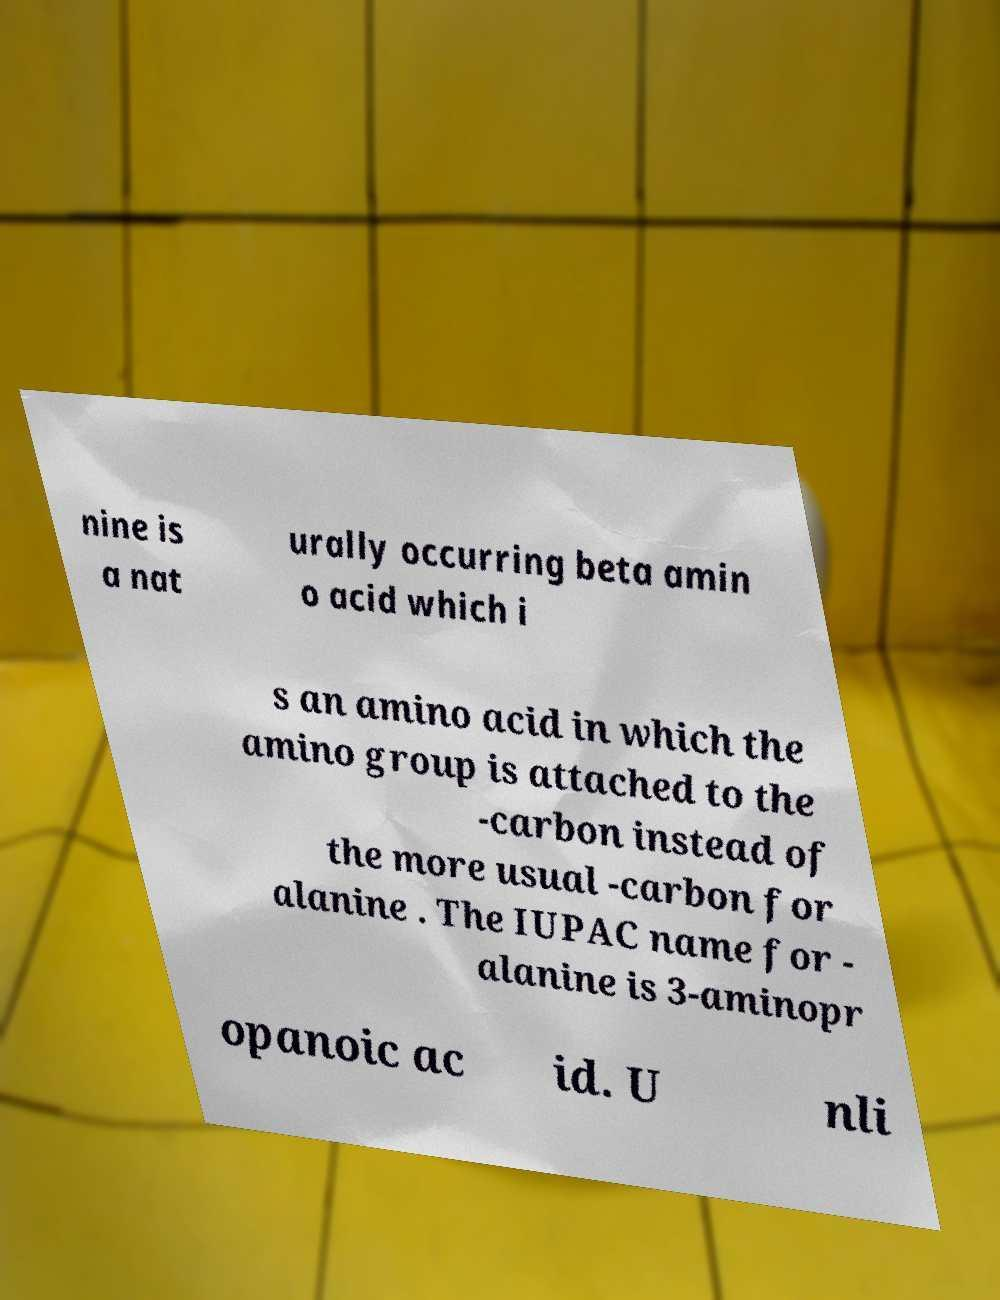Can you accurately transcribe the text from the provided image for me? nine is a nat urally occurring beta amin o acid which i s an amino acid in which the amino group is attached to the -carbon instead of the more usual -carbon for alanine . The IUPAC name for - alanine is 3-aminopr opanoic ac id. U nli 